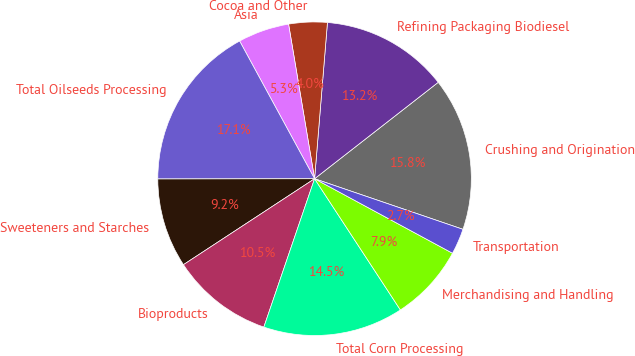Convert chart to OTSL. <chart><loc_0><loc_0><loc_500><loc_500><pie_chart><fcel>Crushing and Origination<fcel>Refining Packaging Biodiesel<fcel>Cocoa and Other<fcel>Asia<fcel>Total Oilseeds Processing<fcel>Sweeteners and Starches<fcel>Bioproducts<fcel>Total Corn Processing<fcel>Merchandising and Handling<fcel>Transportation<nl><fcel>15.77%<fcel>13.15%<fcel>3.96%<fcel>5.28%<fcel>17.09%<fcel>9.21%<fcel>10.52%<fcel>14.46%<fcel>7.9%<fcel>2.65%<nl></chart> 